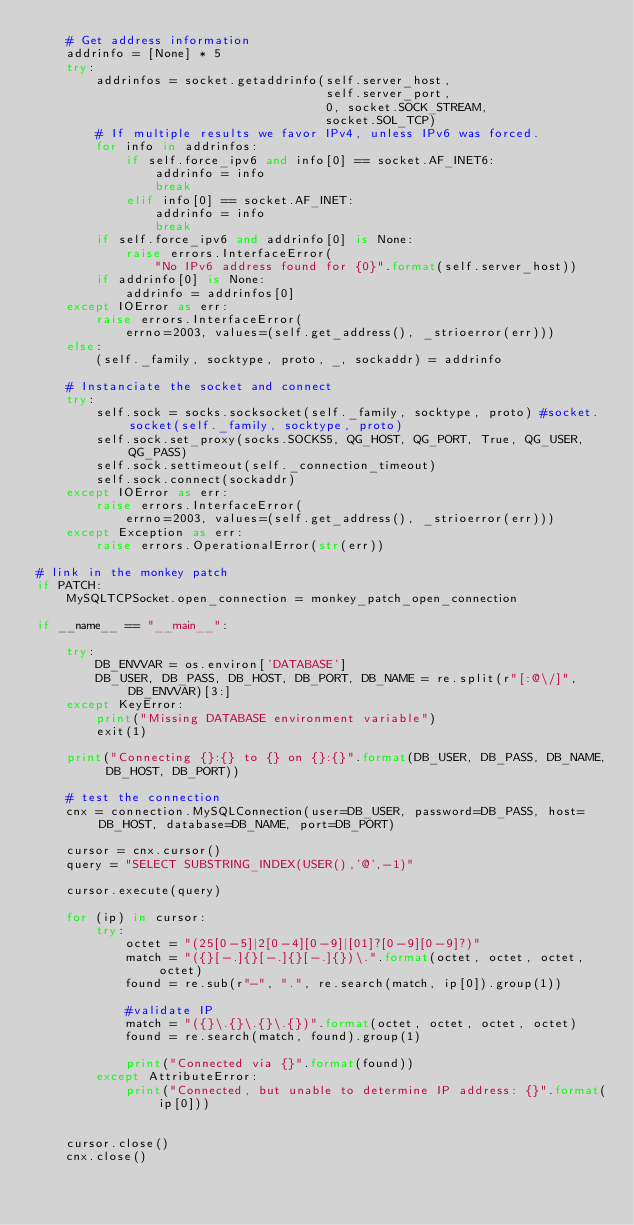<code> <loc_0><loc_0><loc_500><loc_500><_Python_>    # Get address information
    addrinfo = [None] * 5
    try:
        addrinfos = socket.getaddrinfo(self.server_host,
                                       self.server_port,
                                       0, socket.SOCK_STREAM,
                                       socket.SOL_TCP)
        # If multiple results we favor IPv4, unless IPv6 was forced.
        for info in addrinfos:
            if self.force_ipv6 and info[0] == socket.AF_INET6:
                addrinfo = info
                break
            elif info[0] == socket.AF_INET:
                addrinfo = info
                break
        if self.force_ipv6 and addrinfo[0] is None:
            raise errors.InterfaceError(
                "No IPv6 address found for {0}".format(self.server_host))
        if addrinfo[0] is None:
            addrinfo = addrinfos[0]
    except IOError as err:
        raise errors.InterfaceError(
            errno=2003, values=(self.get_address(), _strioerror(err)))
    else:
        (self._family, socktype, proto, _, sockaddr) = addrinfo

    # Instanciate the socket and connect
    try:
        self.sock = socks.socksocket(self._family, socktype, proto) #socket.socket(self._family, socktype, proto)
        self.sock.set_proxy(socks.SOCKS5, QG_HOST, QG_PORT, True, QG_USER, QG_PASS)
        self.sock.settimeout(self._connection_timeout)
        self.sock.connect(sockaddr)
    except IOError as err:
        raise errors.InterfaceError(
            errno=2003, values=(self.get_address(), _strioerror(err)))
    except Exception as err:
        raise errors.OperationalError(str(err))

# link in the monkey patch
if PATCH:
    MySQLTCPSocket.open_connection = monkey_patch_open_connection

if __name__ == "__main__":

    try:
        DB_ENVVAR = os.environ['DATABASE']
        DB_USER, DB_PASS, DB_HOST, DB_PORT, DB_NAME = re.split(r"[:@\/]", DB_ENVVAR)[3:]
    except KeyError:
        print("Missing DATABASE environment variable")
        exit(1)

    print("Connecting {}:{} to {} on {}:{}".format(DB_USER, DB_PASS, DB_NAME, DB_HOST, DB_PORT))

    # test the connection
    cnx = connection.MySQLConnection(user=DB_USER, password=DB_PASS, host=DB_HOST, database=DB_NAME, port=DB_PORT)

    cursor = cnx.cursor()
    query = "SELECT SUBSTRING_INDEX(USER(),'@',-1)"

    cursor.execute(query)

    for (ip) in cursor:
        try:
            octet = "(25[0-5]|2[0-4][0-9]|[01]?[0-9][0-9]?)"
            match = "({}[-.]{}[-.]{}[-.]{})\.".format(octet, octet, octet, octet)
            found = re.sub(r"-", ".", re.search(match, ip[0]).group(1))

            #validate IP
            match = "({}\.{}\.{}\.{})".format(octet, octet, octet, octet)
            found = re.search(match, found).group(1)

            print("Connected via {}".format(found))
        except AttributeError:
            print("Connected, but unable to determine IP address: {}".format(ip[0]))


    cursor.close()
    cnx.close()
</code> 